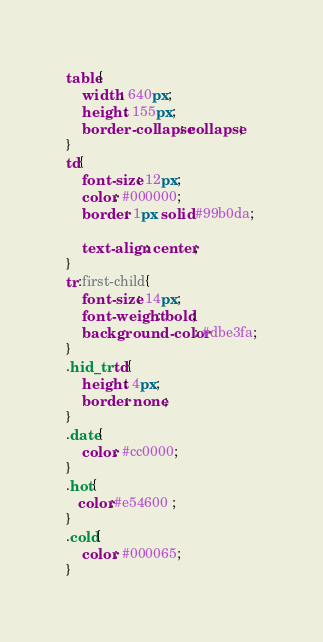Convert code to text. <code><loc_0><loc_0><loc_500><loc_500><_CSS_>table{
    width: 640px;
    height: 155px;
    border-collapse: collapse;  
}
td{
    font-size: 12px;
    color: #000000;
    border: 1px solid #99b0da;
    
    text-align: center;
}
tr:first-child{
    font-size: 14px;
    font-weight: bold;
    background-color: #dbe3fa;
}
.hid_tr td{
    height: 4px;
    border: none;
}
.date{
    color: #cc0000;
}
.hot{
   color:#e54600 ; 
}
.cold{
    color: #000065;
}
</code> 